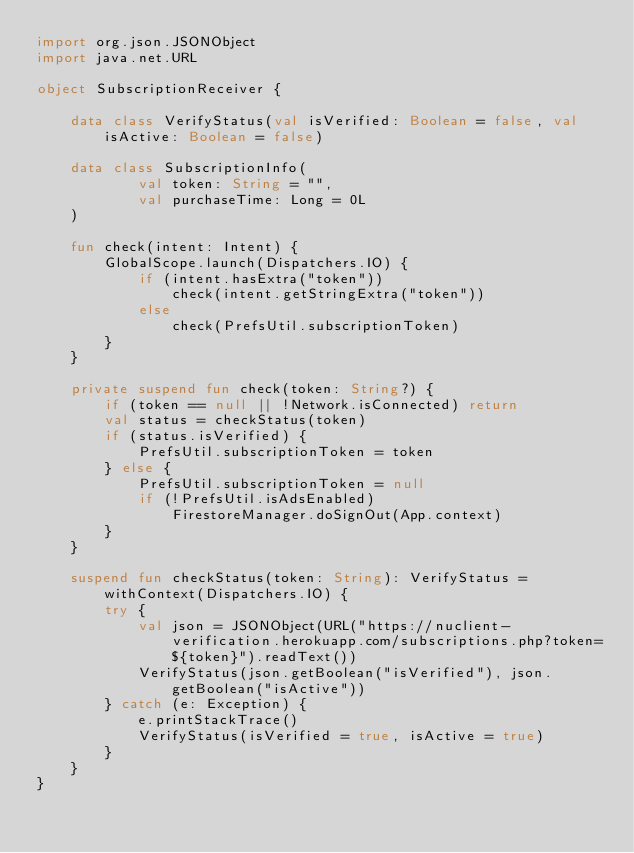<code> <loc_0><loc_0><loc_500><loc_500><_Kotlin_>import org.json.JSONObject
import java.net.URL

object SubscriptionReceiver {

    data class VerifyStatus(val isVerified: Boolean = false, val isActive: Boolean = false)

    data class SubscriptionInfo(
            val token: String = "",
            val purchaseTime: Long = 0L
    )

    fun check(intent: Intent) {
        GlobalScope.launch(Dispatchers.IO) {
            if (intent.hasExtra("token"))
                check(intent.getStringExtra("token"))
            else
                check(PrefsUtil.subscriptionToken)
        }
    }

    private suspend fun check(token: String?) {
        if (token == null || !Network.isConnected) return
        val status = checkStatus(token)
        if (status.isVerified) {
            PrefsUtil.subscriptionToken = token
        } else {
            PrefsUtil.subscriptionToken = null
            if (!PrefsUtil.isAdsEnabled)
                FirestoreManager.doSignOut(App.context)
        }
    }

    suspend fun checkStatus(token: String): VerifyStatus = withContext(Dispatchers.IO) {
        try {
            val json = JSONObject(URL("https://nuclient-verification.herokuapp.com/subscriptions.php?token=${token}").readText())
            VerifyStatus(json.getBoolean("isVerified"), json.getBoolean("isActive"))
        } catch (e: Exception) {
            e.printStackTrace()
            VerifyStatus(isVerified = true, isActive = true)
        }
    }
}</code> 